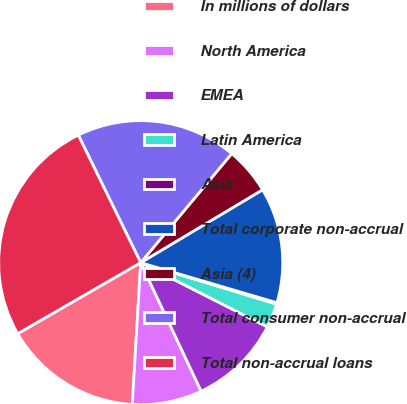<chart> <loc_0><loc_0><loc_500><loc_500><pie_chart><fcel>In millions of dollars<fcel>North America<fcel>EMEA<fcel>Latin America<fcel>Asia<fcel>Total corporate non-accrual<fcel>Asia (4)<fcel>Total consumer non-accrual<fcel>Total non-accrual loans<nl><fcel>15.72%<fcel>7.94%<fcel>10.53%<fcel>2.76%<fcel>0.16%<fcel>13.13%<fcel>5.35%<fcel>18.31%<fcel>26.09%<nl></chart> 